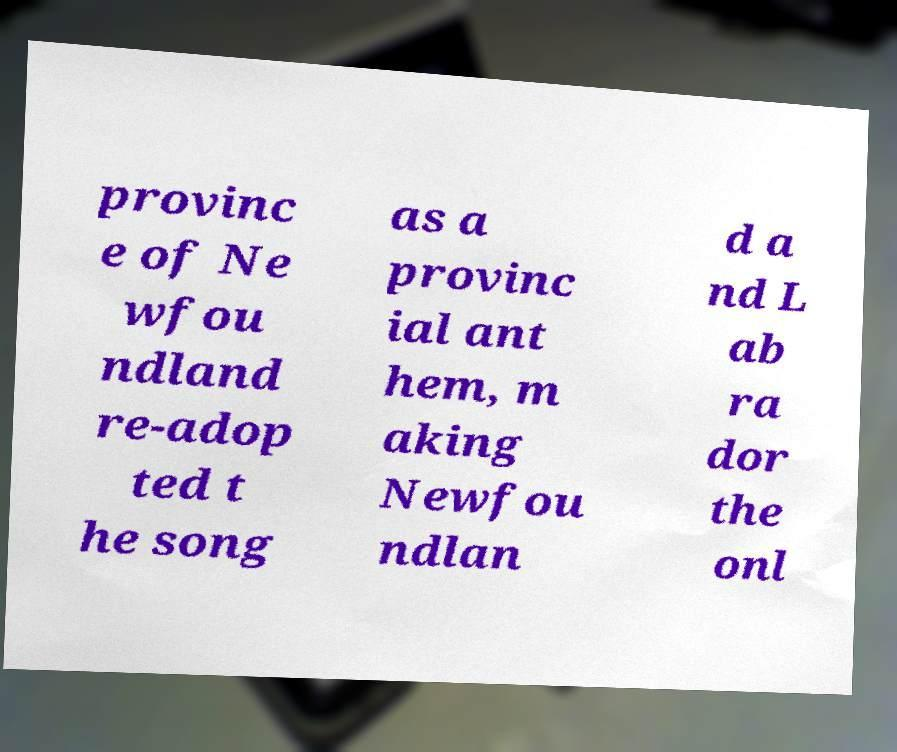Please identify and transcribe the text found in this image. provinc e of Ne wfou ndland re-adop ted t he song as a provinc ial ant hem, m aking Newfou ndlan d a nd L ab ra dor the onl 